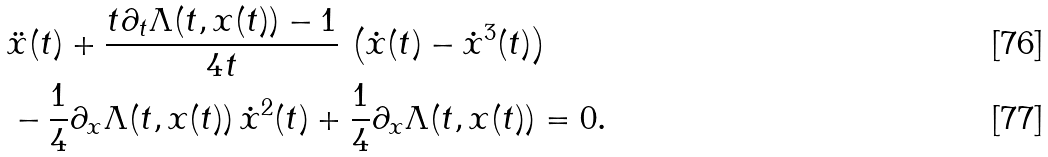Convert formula to latex. <formula><loc_0><loc_0><loc_500><loc_500>& \ddot { x } ( t ) + \frac { t \partial _ { t } \Lambda ( t , x ( t ) ) - 1 } { 4 t } \, \left ( \dot { x } ( t ) - \dot { x } ^ { 3 } ( t ) \right ) \\ & - \frac { 1 } { 4 } \partial _ { x } \Lambda ( t , x ( t ) ) \, \dot { x } ^ { 2 } ( t ) + \frac { 1 } { 4 } \partial _ { x } \Lambda ( t , x ( t ) ) = 0 .</formula> 